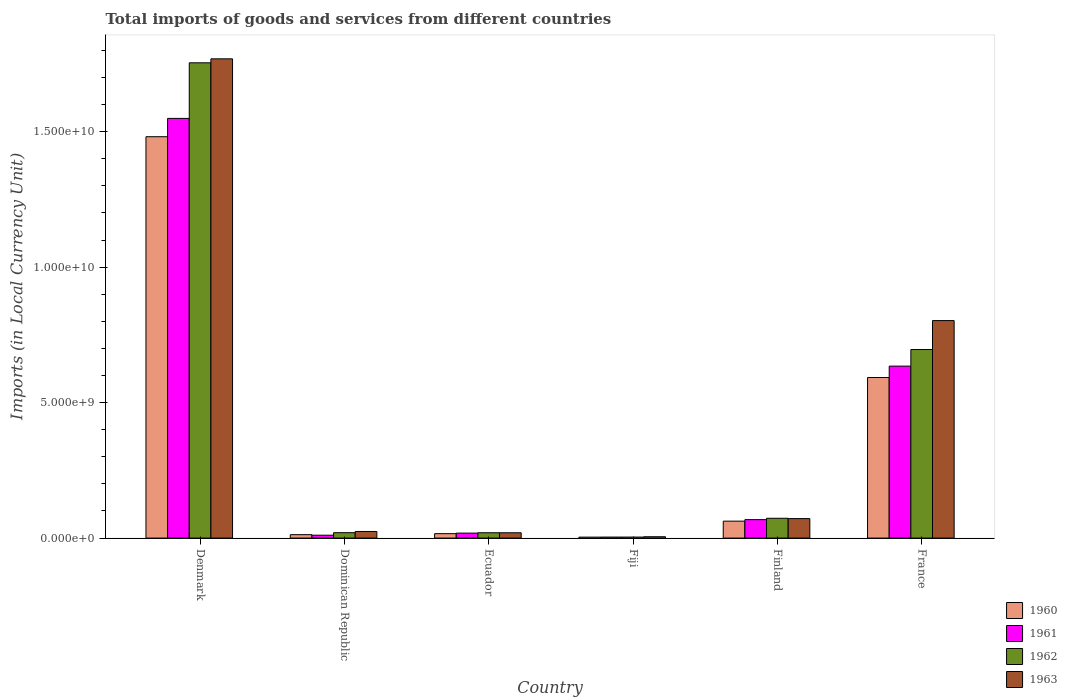Are the number of bars per tick equal to the number of legend labels?
Offer a very short reply. Yes. What is the label of the 4th group of bars from the left?
Make the answer very short. Fiji. In how many cases, is the number of bars for a given country not equal to the number of legend labels?
Provide a short and direct response. 0. What is the Amount of goods and services imports in 1960 in France?
Give a very brief answer. 5.93e+09. Across all countries, what is the maximum Amount of goods and services imports in 1962?
Ensure brevity in your answer.  1.75e+1. Across all countries, what is the minimum Amount of goods and services imports in 1961?
Your response must be concise. 3.79e+07. In which country was the Amount of goods and services imports in 1962 maximum?
Provide a short and direct response. Denmark. In which country was the Amount of goods and services imports in 1961 minimum?
Offer a terse response. Fiji. What is the total Amount of goods and services imports in 1962 in the graph?
Offer a terse response. 2.57e+1. What is the difference between the Amount of goods and services imports in 1961 in Denmark and that in France?
Your response must be concise. 9.14e+09. What is the difference between the Amount of goods and services imports in 1961 in Ecuador and the Amount of goods and services imports in 1960 in Finland?
Your answer should be compact. -4.42e+08. What is the average Amount of goods and services imports in 1961 per country?
Your answer should be compact. 3.81e+09. What is the difference between the Amount of goods and services imports of/in 1960 and Amount of goods and services imports of/in 1961 in Dominican Republic?
Your response must be concise. 1.96e+07. In how many countries, is the Amount of goods and services imports in 1963 greater than 5000000000 LCU?
Ensure brevity in your answer.  2. What is the ratio of the Amount of goods and services imports in 1962 in Dominican Republic to that in Fiji?
Make the answer very short. 5.26. Is the Amount of goods and services imports in 1963 in Ecuador less than that in France?
Provide a short and direct response. Yes. What is the difference between the highest and the second highest Amount of goods and services imports in 1962?
Your answer should be very brief. 1.06e+1. What is the difference between the highest and the lowest Amount of goods and services imports in 1960?
Your response must be concise. 1.48e+1. What does the 4th bar from the right in Ecuador represents?
Give a very brief answer. 1960. Is it the case that in every country, the sum of the Amount of goods and services imports in 1963 and Amount of goods and services imports in 1962 is greater than the Amount of goods and services imports in 1960?
Provide a short and direct response. Yes. How many bars are there?
Keep it short and to the point. 24. Are all the bars in the graph horizontal?
Offer a very short reply. No. What is the difference between two consecutive major ticks on the Y-axis?
Your answer should be compact. 5.00e+09. Are the values on the major ticks of Y-axis written in scientific E-notation?
Your answer should be compact. Yes. Where does the legend appear in the graph?
Your response must be concise. Bottom right. What is the title of the graph?
Make the answer very short. Total imports of goods and services from different countries. Does "1980" appear as one of the legend labels in the graph?
Give a very brief answer. No. What is the label or title of the Y-axis?
Ensure brevity in your answer.  Imports (in Local Currency Unit). What is the Imports (in Local Currency Unit) of 1960 in Denmark?
Ensure brevity in your answer.  1.48e+1. What is the Imports (in Local Currency Unit) in 1961 in Denmark?
Your answer should be very brief. 1.55e+1. What is the Imports (in Local Currency Unit) in 1962 in Denmark?
Your answer should be very brief. 1.75e+1. What is the Imports (in Local Currency Unit) in 1963 in Denmark?
Give a very brief answer. 1.77e+1. What is the Imports (in Local Currency Unit) of 1960 in Dominican Republic?
Provide a short and direct response. 1.26e+08. What is the Imports (in Local Currency Unit) in 1961 in Dominican Republic?
Keep it short and to the point. 1.07e+08. What is the Imports (in Local Currency Unit) of 1962 in Dominican Republic?
Ensure brevity in your answer.  1.99e+08. What is the Imports (in Local Currency Unit) in 1963 in Dominican Republic?
Your answer should be very brief. 2.44e+08. What is the Imports (in Local Currency Unit) of 1960 in Ecuador?
Provide a short and direct response. 1.64e+08. What is the Imports (in Local Currency Unit) of 1961 in Ecuador?
Offer a terse response. 1.83e+08. What is the Imports (in Local Currency Unit) of 1962 in Ecuador?
Provide a short and direct response. 1.97e+08. What is the Imports (in Local Currency Unit) of 1963 in Ecuador?
Provide a succinct answer. 1.96e+08. What is the Imports (in Local Currency Unit) of 1960 in Fiji?
Provide a succinct answer. 3.56e+07. What is the Imports (in Local Currency Unit) of 1961 in Fiji?
Offer a very short reply. 3.79e+07. What is the Imports (in Local Currency Unit) in 1962 in Fiji?
Offer a very short reply. 3.79e+07. What is the Imports (in Local Currency Unit) in 1960 in Finland?
Provide a succinct answer. 6.25e+08. What is the Imports (in Local Currency Unit) of 1961 in Finland?
Ensure brevity in your answer.  6.81e+08. What is the Imports (in Local Currency Unit) in 1962 in Finland?
Give a very brief answer. 7.32e+08. What is the Imports (in Local Currency Unit) in 1963 in Finland?
Ensure brevity in your answer.  7.19e+08. What is the Imports (in Local Currency Unit) in 1960 in France?
Your answer should be very brief. 5.93e+09. What is the Imports (in Local Currency Unit) in 1961 in France?
Your response must be concise. 6.35e+09. What is the Imports (in Local Currency Unit) of 1962 in France?
Your answer should be very brief. 6.96e+09. What is the Imports (in Local Currency Unit) in 1963 in France?
Give a very brief answer. 8.03e+09. Across all countries, what is the maximum Imports (in Local Currency Unit) of 1960?
Make the answer very short. 1.48e+1. Across all countries, what is the maximum Imports (in Local Currency Unit) in 1961?
Your answer should be compact. 1.55e+1. Across all countries, what is the maximum Imports (in Local Currency Unit) in 1962?
Ensure brevity in your answer.  1.75e+1. Across all countries, what is the maximum Imports (in Local Currency Unit) of 1963?
Offer a terse response. 1.77e+1. Across all countries, what is the minimum Imports (in Local Currency Unit) of 1960?
Make the answer very short. 3.56e+07. Across all countries, what is the minimum Imports (in Local Currency Unit) in 1961?
Offer a terse response. 3.79e+07. Across all countries, what is the minimum Imports (in Local Currency Unit) in 1962?
Ensure brevity in your answer.  3.79e+07. Across all countries, what is the minimum Imports (in Local Currency Unit) of 1963?
Give a very brief answer. 5.00e+07. What is the total Imports (in Local Currency Unit) of 1960 in the graph?
Offer a very short reply. 2.17e+1. What is the total Imports (in Local Currency Unit) of 1961 in the graph?
Give a very brief answer. 2.28e+1. What is the total Imports (in Local Currency Unit) of 1962 in the graph?
Provide a short and direct response. 2.57e+1. What is the total Imports (in Local Currency Unit) of 1963 in the graph?
Provide a succinct answer. 2.69e+1. What is the difference between the Imports (in Local Currency Unit) in 1960 in Denmark and that in Dominican Republic?
Offer a very short reply. 1.47e+1. What is the difference between the Imports (in Local Currency Unit) in 1961 in Denmark and that in Dominican Republic?
Offer a very short reply. 1.54e+1. What is the difference between the Imports (in Local Currency Unit) in 1962 in Denmark and that in Dominican Republic?
Provide a short and direct response. 1.73e+1. What is the difference between the Imports (in Local Currency Unit) of 1963 in Denmark and that in Dominican Republic?
Ensure brevity in your answer.  1.74e+1. What is the difference between the Imports (in Local Currency Unit) in 1960 in Denmark and that in Ecuador?
Keep it short and to the point. 1.47e+1. What is the difference between the Imports (in Local Currency Unit) in 1961 in Denmark and that in Ecuador?
Ensure brevity in your answer.  1.53e+1. What is the difference between the Imports (in Local Currency Unit) in 1962 in Denmark and that in Ecuador?
Ensure brevity in your answer.  1.73e+1. What is the difference between the Imports (in Local Currency Unit) in 1963 in Denmark and that in Ecuador?
Make the answer very short. 1.75e+1. What is the difference between the Imports (in Local Currency Unit) of 1960 in Denmark and that in Fiji?
Provide a short and direct response. 1.48e+1. What is the difference between the Imports (in Local Currency Unit) in 1961 in Denmark and that in Fiji?
Ensure brevity in your answer.  1.55e+1. What is the difference between the Imports (in Local Currency Unit) of 1962 in Denmark and that in Fiji?
Your answer should be compact. 1.75e+1. What is the difference between the Imports (in Local Currency Unit) of 1963 in Denmark and that in Fiji?
Your answer should be very brief. 1.76e+1. What is the difference between the Imports (in Local Currency Unit) in 1960 in Denmark and that in Finland?
Give a very brief answer. 1.42e+1. What is the difference between the Imports (in Local Currency Unit) in 1961 in Denmark and that in Finland?
Your response must be concise. 1.48e+1. What is the difference between the Imports (in Local Currency Unit) in 1962 in Denmark and that in Finland?
Make the answer very short. 1.68e+1. What is the difference between the Imports (in Local Currency Unit) in 1963 in Denmark and that in Finland?
Give a very brief answer. 1.70e+1. What is the difference between the Imports (in Local Currency Unit) of 1960 in Denmark and that in France?
Offer a very short reply. 8.89e+09. What is the difference between the Imports (in Local Currency Unit) of 1961 in Denmark and that in France?
Your answer should be very brief. 9.14e+09. What is the difference between the Imports (in Local Currency Unit) of 1962 in Denmark and that in France?
Provide a short and direct response. 1.06e+1. What is the difference between the Imports (in Local Currency Unit) of 1963 in Denmark and that in France?
Provide a short and direct response. 9.66e+09. What is the difference between the Imports (in Local Currency Unit) in 1960 in Dominican Republic and that in Ecuador?
Provide a short and direct response. -3.75e+07. What is the difference between the Imports (in Local Currency Unit) in 1961 in Dominican Republic and that in Ecuador?
Your answer should be compact. -7.66e+07. What is the difference between the Imports (in Local Currency Unit) of 1962 in Dominican Republic and that in Ecuador?
Your answer should be compact. 2.37e+06. What is the difference between the Imports (in Local Currency Unit) in 1963 in Dominican Republic and that in Ecuador?
Ensure brevity in your answer.  4.81e+07. What is the difference between the Imports (in Local Currency Unit) in 1960 in Dominican Republic and that in Fiji?
Keep it short and to the point. 9.09e+07. What is the difference between the Imports (in Local Currency Unit) in 1961 in Dominican Republic and that in Fiji?
Keep it short and to the point. 6.90e+07. What is the difference between the Imports (in Local Currency Unit) in 1962 in Dominican Republic and that in Fiji?
Provide a short and direct response. 1.61e+08. What is the difference between the Imports (in Local Currency Unit) in 1963 in Dominican Republic and that in Fiji?
Provide a succinct answer. 1.94e+08. What is the difference between the Imports (in Local Currency Unit) of 1960 in Dominican Republic and that in Finland?
Offer a terse response. -4.99e+08. What is the difference between the Imports (in Local Currency Unit) in 1961 in Dominican Republic and that in Finland?
Your answer should be very brief. -5.75e+08. What is the difference between the Imports (in Local Currency Unit) of 1962 in Dominican Republic and that in Finland?
Your response must be concise. -5.32e+08. What is the difference between the Imports (in Local Currency Unit) in 1963 in Dominican Republic and that in Finland?
Keep it short and to the point. -4.75e+08. What is the difference between the Imports (in Local Currency Unit) in 1960 in Dominican Republic and that in France?
Offer a very short reply. -5.80e+09. What is the difference between the Imports (in Local Currency Unit) in 1961 in Dominican Republic and that in France?
Offer a terse response. -6.24e+09. What is the difference between the Imports (in Local Currency Unit) of 1962 in Dominican Republic and that in France?
Provide a succinct answer. -6.76e+09. What is the difference between the Imports (in Local Currency Unit) of 1963 in Dominican Republic and that in France?
Keep it short and to the point. -7.78e+09. What is the difference between the Imports (in Local Currency Unit) in 1960 in Ecuador and that in Fiji?
Your answer should be very brief. 1.28e+08. What is the difference between the Imports (in Local Currency Unit) in 1961 in Ecuador and that in Fiji?
Your response must be concise. 1.46e+08. What is the difference between the Imports (in Local Currency Unit) of 1962 in Ecuador and that in Fiji?
Your answer should be very brief. 1.59e+08. What is the difference between the Imports (in Local Currency Unit) of 1963 in Ecuador and that in Fiji?
Your response must be concise. 1.46e+08. What is the difference between the Imports (in Local Currency Unit) of 1960 in Ecuador and that in Finland?
Provide a short and direct response. -4.61e+08. What is the difference between the Imports (in Local Currency Unit) in 1961 in Ecuador and that in Finland?
Keep it short and to the point. -4.98e+08. What is the difference between the Imports (in Local Currency Unit) in 1962 in Ecuador and that in Finland?
Make the answer very short. -5.35e+08. What is the difference between the Imports (in Local Currency Unit) in 1963 in Ecuador and that in Finland?
Offer a terse response. -5.23e+08. What is the difference between the Imports (in Local Currency Unit) of 1960 in Ecuador and that in France?
Your response must be concise. -5.76e+09. What is the difference between the Imports (in Local Currency Unit) of 1961 in Ecuador and that in France?
Your response must be concise. -6.16e+09. What is the difference between the Imports (in Local Currency Unit) of 1962 in Ecuador and that in France?
Your answer should be very brief. -6.76e+09. What is the difference between the Imports (in Local Currency Unit) of 1963 in Ecuador and that in France?
Your answer should be very brief. -7.83e+09. What is the difference between the Imports (in Local Currency Unit) in 1960 in Fiji and that in Finland?
Ensure brevity in your answer.  -5.90e+08. What is the difference between the Imports (in Local Currency Unit) of 1961 in Fiji and that in Finland?
Give a very brief answer. -6.44e+08. What is the difference between the Imports (in Local Currency Unit) in 1962 in Fiji and that in Finland?
Your response must be concise. -6.94e+08. What is the difference between the Imports (in Local Currency Unit) in 1963 in Fiji and that in Finland?
Provide a short and direct response. -6.69e+08. What is the difference between the Imports (in Local Currency Unit) in 1960 in Fiji and that in France?
Your answer should be compact. -5.89e+09. What is the difference between the Imports (in Local Currency Unit) in 1961 in Fiji and that in France?
Your answer should be very brief. -6.31e+09. What is the difference between the Imports (in Local Currency Unit) in 1962 in Fiji and that in France?
Offer a very short reply. -6.92e+09. What is the difference between the Imports (in Local Currency Unit) of 1963 in Fiji and that in France?
Keep it short and to the point. -7.98e+09. What is the difference between the Imports (in Local Currency Unit) of 1960 in Finland and that in France?
Make the answer very short. -5.30e+09. What is the difference between the Imports (in Local Currency Unit) in 1961 in Finland and that in France?
Provide a succinct answer. -5.67e+09. What is the difference between the Imports (in Local Currency Unit) of 1962 in Finland and that in France?
Keep it short and to the point. -6.23e+09. What is the difference between the Imports (in Local Currency Unit) in 1963 in Finland and that in France?
Keep it short and to the point. -7.31e+09. What is the difference between the Imports (in Local Currency Unit) in 1960 in Denmark and the Imports (in Local Currency Unit) in 1961 in Dominican Republic?
Make the answer very short. 1.47e+1. What is the difference between the Imports (in Local Currency Unit) in 1960 in Denmark and the Imports (in Local Currency Unit) in 1962 in Dominican Republic?
Your answer should be compact. 1.46e+1. What is the difference between the Imports (in Local Currency Unit) of 1960 in Denmark and the Imports (in Local Currency Unit) of 1963 in Dominican Republic?
Give a very brief answer. 1.46e+1. What is the difference between the Imports (in Local Currency Unit) of 1961 in Denmark and the Imports (in Local Currency Unit) of 1962 in Dominican Republic?
Your answer should be compact. 1.53e+1. What is the difference between the Imports (in Local Currency Unit) in 1961 in Denmark and the Imports (in Local Currency Unit) in 1963 in Dominican Republic?
Offer a terse response. 1.52e+1. What is the difference between the Imports (in Local Currency Unit) in 1962 in Denmark and the Imports (in Local Currency Unit) in 1963 in Dominican Republic?
Offer a very short reply. 1.73e+1. What is the difference between the Imports (in Local Currency Unit) of 1960 in Denmark and the Imports (in Local Currency Unit) of 1961 in Ecuador?
Offer a terse response. 1.46e+1. What is the difference between the Imports (in Local Currency Unit) in 1960 in Denmark and the Imports (in Local Currency Unit) in 1962 in Ecuador?
Your answer should be compact. 1.46e+1. What is the difference between the Imports (in Local Currency Unit) in 1960 in Denmark and the Imports (in Local Currency Unit) in 1963 in Ecuador?
Your answer should be compact. 1.46e+1. What is the difference between the Imports (in Local Currency Unit) in 1961 in Denmark and the Imports (in Local Currency Unit) in 1962 in Ecuador?
Give a very brief answer. 1.53e+1. What is the difference between the Imports (in Local Currency Unit) of 1961 in Denmark and the Imports (in Local Currency Unit) of 1963 in Ecuador?
Keep it short and to the point. 1.53e+1. What is the difference between the Imports (in Local Currency Unit) of 1962 in Denmark and the Imports (in Local Currency Unit) of 1963 in Ecuador?
Give a very brief answer. 1.73e+1. What is the difference between the Imports (in Local Currency Unit) in 1960 in Denmark and the Imports (in Local Currency Unit) in 1961 in Fiji?
Offer a terse response. 1.48e+1. What is the difference between the Imports (in Local Currency Unit) in 1960 in Denmark and the Imports (in Local Currency Unit) in 1962 in Fiji?
Your answer should be compact. 1.48e+1. What is the difference between the Imports (in Local Currency Unit) of 1960 in Denmark and the Imports (in Local Currency Unit) of 1963 in Fiji?
Keep it short and to the point. 1.48e+1. What is the difference between the Imports (in Local Currency Unit) in 1961 in Denmark and the Imports (in Local Currency Unit) in 1962 in Fiji?
Ensure brevity in your answer.  1.55e+1. What is the difference between the Imports (in Local Currency Unit) in 1961 in Denmark and the Imports (in Local Currency Unit) in 1963 in Fiji?
Ensure brevity in your answer.  1.54e+1. What is the difference between the Imports (in Local Currency Unit) of 1962 in Denmark and the Imports (in Local Currency Unit) of 1963 in Fiji?
Your response must be concise. 1.75e+1. What is the difference between the Imports (in Local Currency Unit) of 1960 in Denmark and the Imports (in Local Currency Unit) of 1961 in Finland?
Your answer should be compact. 1.41e+1. What is the difference between the Imports (in Local Currency Unit) in 1960 in Denmark and the Imports (in Local Currency Unit) in 1962 in Finland?
Offer a very short reply. 1.41e+1. What is the difference between the Imports (in Local Currency Unit) of 1960 in Denmark and the Imports (in Local Currency Unit) of 1963 in Finland?
Make the answer very short. 1.41e+1. What is the difference between the Imports (in Local Currency Unit) in 1961 in Denmark and the Imports (in Local Currency Unit) in 1962 in Finland?
Your answer should be compact. 1.48e+1. What is the difference between the Imports (in Local Currency Unit) of 1961 in Denmark and the Imports (in Local Currency Unit) of 1963 in Finland?
Ensure brevity in your answer.  1.48e+1. What is the difference between the Imports (in Local Currency Unit) of 1962 in Denmark and the Imports (in Local Currency Unit) of 1963 in Finland?
Keep it short and to the point. 1.68e+1. What is the difference between the Imports (in Local Currency Unit) of 1960 in Denmark and the Imports (in Local Currency Unit) of 1961 in France?
Offer a very short reply. 8.47e+09. What is the difference between the Imports (in Local Currency Unit) in 1960 in Denmark and the Imports (in Local Currency Unit) in 1962 in France?
Provide a succinct answer. 7.85e+09. What is the difference between the Imports (in Local Currency Unit) in 1960 in Denmark and the Imports (in Local Currency Unit) in 1963 in France?
Your answer should be compact. 6.79e+09. What is the difference between the Imports (in Local Currency Unit) in 1961 in Denmark and the Imports (in Local Currency Unit) in 1962 in France?
Give a very brief answer. 8.53e+09. What is the difference between the Imports (in Local Currency Unit) of 1961 in Denmark and the Imports (in Local Currency Unit) of 1963 in France?
Your answer should be compact. 7.46e+09. What is the difference between the Imports (in Local Currency Unit) of 1962 in Denmark and the Imports (in Local Currency Unit) of 1963 in France?
Give a very brief answer. 9.51e+09. What is the difference between the Imports (in Local Currency Unit) of 1960 in Dominican Republic and the Imports (in Local Currency Unit) of 1961 in Ecuador?
Your answer should be compact. -5.70e+07. What is the difference between the Imports (in Local Currency Unit) in 1960 in Dominican Republic and the Imports (in Local Currency Unit) in 1962 in Ecuador?
Offer a terse response. -7.04e+07. What is the difference between the Imports (in Local Currency Unit) in 1960 in Dominican Republic and the Imports (in Local Currency Unit) in 1963 in Ecuador?
Your response must be concise. -6.98e+07. What is the difference between the Imports (in Local Currency Unit) of 1961 in Dominican Republic and the Imports (in Local Currency Unit) of 1962 in Ecuador?
Offer a terse response. -9.00e+07. What is the difference between the Imports (in Local Currency Unit) in 1961 in Dominican Republic and the Imports (in Local Currency Unit) in 1963 in Ecuador?
Ensure brevity in your answer.  -8.94e+07. What is the difference between the Imports (in Local Currency Unit) in 1962 in Dominican Republic and the Imports (in Local Currency Unit) in 1963 in Ecuador?
Offer a terse response. 3.04e+06. What is the difference between the Imports (in Local Currency Unit) in 1960 in Dominican Republic and the Imports (in Local Currency Unit) in 1961 in Fiji?
Your response must be concise. 8.86e+07. What is the difference between the Imports (in Local Currency Unit) in 1960 in Dominican Republic and the Imports (in Local Currency Unit) in 1962 in Fiji?
Ensure brevity in your answer.  8.86e+07. What is the difference between the Imports (in Local Currency Unit) of 1960 in Dominican Republic and the Imports (in Local Currency Unit) of 1963 in Fiji?
Your answer should be very brief. 7.65e+07. What is the difference between the Imports (in Local Currency Unit) of 1961 in Dominican Republic and the Imports (in Local Currency Unit) of 1962 in Fiji?
Your answer should be compact. 6.90e+07. What is the difference between the Imports (in Local Currency Unit) of 1961 in Dominican Republic and the Imports (in Local Currency Unit) of 1963 in Fiji?
Offer a terse response. 5.69e+07. What is the difference between the Imports (in Local Currency Unit) of 1962 in Dominican Republic and the Imports (in Local Currency Unit) of 1963 in Fiji?
Provide a succinct answer. 1.49e+08. What is the difference between the Imports (in Local Currency Unit) of 1960 in Dominican Republic and the Imports (in Local Currency Unit) of 1961 in Finland?
Offer a terse response. -5.55e+08. What is the difference between the Imports (in Local Currency Unit) in 1960 in Dominican Republic and the Imports (in Local Currency Unit) in 1962 in Finland?
Make the answer very short. -6.05e+08. What is the difference between the Imports (in Local Currency Unit) in 1960 in Dominican Republic and the Imports (in Local Currency Unit) in 1963 in Finland?
Give a very brief answer. -5.93e+08. What is the difference between the Imports (in Local Currency Unit) of 1961 in Dominican Republic and the Imports (in Local Currency Unit) of 1962 in Finland?
Provide a succinct answer. -6.25e+08. What is the difference between the Imports (in Local Currency Unit) of 1961 in Dominican Republic and the Imports (in Local Currency Unit) of 1963 in Finland?
Offer a very short reply. -6.12e+08. What is the difference between the Imports (in Local Currency Unit) in 1962 in Dominican Republic and the Imports (in Local Currency Unit) in 1963 in Finland?
Your response must be concise. -5.20e+08. What is the difference between the Imports (in Local Currency Unit) of 1960 in Dominican Republic and the Imports (in Local Currency Unit) of 1961 in France?
Give a very brief answer. -6.22e+09. What is the difference between the Imports (in Local Currency Unit) of 1960 in Dominican Republic and the Imports (in Local Currency Unit) of 1962 in France?
Ensure brevity in your answer.  -6.83e+09. What is the difference between the Imports (in Local Currency Unit) in 1960 in Dominican Republic and the Imports (in Local Currency Unit) in 1963 in France?
Your answer should be very brief. -7.90e+09. What is the difference between the Imports (in Local Currency Unit) of 1961 in Dominican Republic and the Imports (in Local Currency Unit) of 1962 in France?
Provide a succinct answer. -6.85e+09. What is the difference between the Imports (in Local Currency Unit) of 1961 in Dominican Republic and the Imports (in Local Currency Unit) of 1963 in France?
Ensure brevity in your answer.  -7.92e+09. What is the difference between the Imports (in Local Currency Unit) in 1962 in Dominican Republic and the Imports (in Local Currency Unit) in 1963 in France?
Provide a succinct answer. -7.83e+09. What is the difference between the Imports (in Local Currency Unit) in 1960 in Ecuador and the Imports (in Local Currency Unit) in 1961 in Fiji?
Your response must be concise. 1.26e+08. What is the difference between the Imports (in Local Currency Unit) of 1960 in Ecuador and the Imports (in Local Currency Unit) of 1962 in Fiji?
Give a very brief answer. 1.26e+08. What is the difference between the Imports (in Local Currency Unit) in 1960 in Ecuador and the Imports (in Local Currency Unit) in 1963 in Fiji?
Your answer should be very brief. 1.14e+08. What is the difference between the Imports (in Local Currency Unit) of 1961 in Ecuador and the Imports (in Local Currency Unit) of 1962 in Fiji?
Your answer should be compact. 1.46e+08. What is the difference between the Imports (in Local Currency Unit) in 1961 in Ecuador and the Imports (in Local Currency Unit) in 1963 in Fiji?
Provide a succinct answer. 1.33e+08. What is the difference between the Imports (in Local Currency Unit) of 1962 in Ecuador and the Imports (in Local Currency Unit) of 1963 in Fiji?
Give a very brief answer. 1.47e+08. What is the difference between the Imports (in Local Currency Unit) of 1960 in Ecuador and the Imports (in Local Currency Unit) of 1961 in Finland?
Offer a terse response. -5.17e+08. What is the difference between the Imports (in Local Currency Unit) in 1960 in Ecuador and the Imports (in Local Currency Unit) in 1962 in Finland?
Ensure brevity in your answer.  -5.68e+08. What is the difference between the Imports (in Local Currency Unit) in 1960 in Ecuador and the Imports (in Local Currency Unit) in 1963 in Finland?
Keep it short and to the point. -5.55e+08. What is the difference between the Imports (in Local Currency Unit) in 1961 in Ecuador and the Imports (in Local Currency Unit) in 1962 in Finland?
Make the answer very short. -5.48e+08. What is the difference between the Imports (in Local Currency Unit) in 1961 in Ecuador and the Imports (in Local Currency Unit) in 1963 in Finland?
Keep it short and to the point. -5.36e+08. What is the difference between the Imports (in Local Currency Unit) of 1962 in Ecuador and the Imports (in Local Currency Unit) of 1963 in Finland?
Make the answer very short. -5.22e+08. What is the difference between the Imports (in Local Currency Unit) of 1960 in Ecuador and the Imports (in Local Currency Unit) of 1961 in France?
Ensure brevity in your answer.  -6.18e+09. What is the difference between the Imports (in Local Currency Unit) in 1960 in Ecuador and the Imports (in Local Currency Unit) in 1962 in France?
Provide a succinct answer. -6.80e+09. What is the difference between the Imports (in Local Currency Unit) of 1960 in Ecuador and the Imports (in Local Currency Unit) of 1963 in France?
Give a very brief answer. -7.86e+09. What is the difference between the Imports (in Local Currency Unit) in 1961 in Ecuador and the Imports (in Local Currency Unit) in 1962 in France?
Your answer should be very brief. -6.78e+09. What is the difference between the Imports (in Local Currency Unit) in 1961 in Ecuador and the Imports (in Local Currency Unit) in 1963 in France?
Ensure brevity in your answer.  -7.84e+09. What is the difference between the Imports (in Local Currency Unit) in 1962 in Ecuador and the Imports (in Local Currency Unit) in 1963 in France?
Your response must be concise. -7.83e+09. What is the difference between the Imports (in Local Currency Unit) in 1960 in Fiji and the Imports (in Local Currency Unit) in 1961 in Finland?
Give a very brief answer. -6.46e+08. What is the difference between the Imports (in Local Currency Unit) in 1960 in Fiji and the Imports (in Local Currency Unit) in 1962 in Finland?
Ensure brevity in your answer.  -6.96e+08. What is the difference between the Imports (in Local Currency Unit) in 1960 in Fiji and the Imports (in Local Currency Unit) in 1963 in Finland?
Provide a succinct answer. -6.84e+08. What is the difference between the Imports (in Local Currency Unit) in 1961 in Fiji and the Imports (in Local Currency Unit) in 1962 in Finland?
Offer a very short reply. -6.94e+08. What is the difference between the Imports (in Local Currency Unit) of 1961 in Fiji and the Imports (in Local Currency Unit) of 1963 in Finland?
Make the answer very short. -6.81e+08. What is the difference between the Imports (in Local Currency Unit) of 1962 in Fiji and the Imports (in Local Currency Unit) of 1963 in Finland?
Keep it short and to the point. -6.81e+08. What is the difference between the Imports (in Local Currency Unit) in 1960 in Fiji and the Imports (in Local Currency Unit) in 1961 in France?
Make the answer very short. -6.31e+09. What is the difference between the Imports (in Local Currency Unit) in 1960 in Fiji and the Imports (in Local Currency Unit) in 1962 in France?
Provide a short and direct response. -6.92e+09. What is the difference between the Imports (in Local Currency Unit) of 1960 in Fiji and the Imports (in Local Currency Unit) of 1963 in France?
Offer a very short reply. -7.99e+09. What is the difference between the Imports (in Local Currency Unit) of 1961 in Fiji and the Imports (in Local Currency Unit) of 1962 in France?
Make the answer very short. -6.92e+09. What is the difference between the Imports (in Local Currency Unit) of 1961 in Fiji and the Imports (in Local Currency Unit) of 1963 in France?
Make the answer very short. -7.99e+09. What is the difference between the Imports (in Local Currency Unit) in 1962 in Fiji and the Imports (in Local Currency Unit) in 1963 in France?
Provide a short and direct response. -7.99e+09. What is the difference between the Imports (in Local Currency Unit) of 1960 in Finland and the Imports (in Local Currency Unit) of 1961 in France?
Offer a very short reply. -5.72e+09. What is the difference between the Imports (in Local Currency Unit) of 1960 in Finland and the Imports (in Local Currency Unit) of 1962 in France?
Your response must be concise. -6.33e+09. What is the difference between the Imports (in Local Currency Unit) in 1960 in Finland and the Imports (in Local Currency Unit) in 1963 in France?
Provide a short and direct response. -7.40e+09. What is the difference between the Imports (in Local Currency Unit) of 1961 in Finland and the Imports (in Local Currency Unit) of 1962 in France?
Give a very brief answer. -6.28e+09. What is the difference between the Imports (in Local Currency Unit) in 1961 in Finland and the Imports (in Local Currency Unit) in 1963 in France?
Make the answer very short. -7.35e+09. What is the difference between the Imports (in Local Currency Unit) of 1962 in Finland and the Imports (in Local Currency Unit) of 1963 in France?
Your response must be concise. -7.30e+09. What is the average Imports (in Local Currency Unit) of 1960 per country?
Give a very brief answer. 3.62e+09. What is the average Imports (in Local Currency Unit) of 1961 per country?
Provide a short and direct response. 3.81e+09. What is the average Imports (in Local Currency Unit) of 1962 per country?
Provide a succinct answer. 4.28e+09. What is the average Imports (in Local Currency Unit) in 1963 per country?
Offer a very short reply. 4.49e+09. What is the difference between the Imports (in Local Currency Unit) in 1960 and Imports (in Local Currency Unit) in 1961 in Denmark?
Your answer should be very brief. -6.76e+08. What is the difference between the Imports (in Local Currency Unit) of 1960 and Imports (in Local Currency Unit) of 1962 in Denmark?
Make the answer very short. -2.73e+09. What is the difference between the Imports (in Local Currency Unit) of 1960 and Imports (in Local Currency Unit) of 1963 in Denmark?
Keep it short and to the point. -2.87e+09. What is the difference between the Imports (in Local Currency Unit) in 1961 and Imports (in Local Currency Unit) in 1962 in Denmark?
Your answer should be very brief. -2.05e+09. What is the difference between the Imports (in Local Currency Unit) in 1961 and Imports (in Local Currency Unit) in 1963 in Denmark?
Offer a very short reply. -2.20e+09. What is the difference between the Imports (in Local Currency Unit) in 1962 and Imports (in Local Currency Unit) in 1963 in Denmark?
Give a very brief answer. -1.47e+08. What is the difference between the Imports (in Local Currency Unit) in 1960 and Imports (in Local Currency Unit) in 1961 in Dominican Republic?
Your answer should be very brief. 1.96e+07. What is the difference between the Imports (in Local Currency Unit) in 1960 and Imports (in Local Currency Unit) in 1962 in Dominican Republic?
Give a very brief answer. -7.28e+07. What is the difference between the Imports (in Local Currency Unit) of 1960 and Imports (in Local Currency Unit) of 1963 in Dominican Republic?
Make the answer very short. -1.18e+08. What is the difference between the Imports (in Local Currency Unit) of 1961 and Imports (in Local Currency Unit) of 1962 in Dominican Republic?
Your answer should be very brief. -9.24e+07. What is the difference between the Imports (in Local Currency Unit) of 1961 and Imports (in Local Currency Unit) of 1963 in Dominican Republic?
Your answer should be compact. -1.38e+08. What is the difference between the Imports (in Local Currency Unit) of 1962 and Imports (in Local Currency Unit) of 1963 in Dominican Republic?
Provide a succinct answer. -4.51e+07. What is the difference between the Imports (in Local Currency Unit) of 1960 and Imports (in Local Currency Unit) of 1961 in Ecuador?
Offer a very short reply. -1.95e+07. What is the difference between the Imports (in Local Currency Unit) of 1960 and Imports (in Local Currency Unit) of 1962 in Ecuador?
Offer a very short reply. -3.29e+07. What is the difference between the Imports (in Local Currency Unit) of 1960 and Imports (in Local Currency Unit) of 1963 in Ecuador?
Your response must be concise. -3.23e+07. What is the difference between the Imports (in Local Currency Unit) in 1961 and Imports (in Local Currency Unit) in 1962 in Ecuador?
Provide a succinct answer. -1.34e+07. What is the difference between the Imports (in Local Currency Unit) in 1961 and Imports (in Local Currency Unit) in 1963 in Ecuador?
Provide a short and direct response. -1.28e+07. What is the difference between the Imports (in Local Currency Unit) of 1962 and Imports (in Local Currency Unit) of 1963 in Ecuador?
Provide a succinct answer. 6.72e+05. What is the difference between the Imports (in Local Currency Unit) of 1960 and Imports (in Local Currency Unit) of 1961 in Fiji?
Your answer should be compact. -2.30e+06. What is the difference between the Imports (in Local Currency Unit) of 1960 and Imports (in Local Currency Unit) of 1962 in Fiji?
Offer a very short reply. -2.30e+06. What is the difference between the Imports (in Local Currency Unit) of 1960 and Imports (in Local Currency Unit) of 1963 in Fiji?
Your answer should be very brief. -1.44e+07. What is the difference between the Imports (in Local Currency Unit) in 1961 and Imports (in Local Currency Unit) in 1962 in Fiji?
Provide a succinct answer. 0. What is the difference between the Imports (in Local Currency Unit) of 1961 and Imports (in Local Currency Unit) of 1963 in Fiji?
Keep it short and to the point. -1.21e+07. What is the difference between the Imports (in Local Currency Unit) in 1962 and Imports (in Local Currency Unit) in 1963 in Fiji?
Provide a short and direct response. -1.21e+07. What is the difference between the Imports (in Local Currency Unit) of 1960 and Imports (in Local Currency Unit) of 1961 in Finland?
Provide a succinct answer. -5.61e+07. What is the difference between the Imports (in Local Currency Unit) in 1960 and Imports (in Local Currency Unit) in 1962 in Finland?
Keep it short and to the point. -1.06e+08. What is the difference between the Imports (in Local Currency Unit) of 1960 and Imports (in Local Currency Unit) of 1963 in Finland?
Your answer should be compact. -9.39e+07. What is the difference between the Imports (in Local Currency Unit) in 1961 and Imports (in Local Currency Unit) in 1962 in Finland?
Keep it short and to the point. -5.01e+07. What is the difference between the Imports (in Local Currency Unit) in 1961 and Imports (in Local Currency Unit) in 1963 in Finland?
Make the answer very short. -3.78e+07. What is the difference between the Imports (in Local Currency Unit) in 1962 and Imports (in Local Currency Unit) in 1963 in Finland?
Give a very brief answer. 1.23e+07. What is the difference between the Imports (in Local Currency Unit) in 1960 and Imports (in Local Currency Unit) in 1961 in France?
Your answer should be compact. -4.20e+08. What is the difference between the Imports (in Local Currency Unit) in 1960 and Imports (in Local Currency Unit) in 1962 in France?
Give a very brief answer. -1.03e+09. What is the difference between the Imports (in Local Currency Unit) in 1960 and Imports (in Local Currency Unit) in 1963 in France?
Ensure brevity in your answer.  -2.10e+09. What is the difference between the Imports (in Local Currency Unit) of 1961 and Imports (in Local Currency Unit) of 1962 in France?
Offer a very short reply. -6.12e+08. What is the difference between the Imports (in Local Currency Unit) in 1961 and Imports (in Local Currency Unit) in 1963 in France?
Offer a very short reply. -1.68e+09. What is the difference between the Imports (in Local Currency Unit) of 1962 and Imports (in Local Currency Unit) of 1963 in France?
Ensure brevity in your answer.  -1.07e+09. What is the ratio of the Imports (in Local Currency Unit) in 1960 in Denmark to that in Dominican Republic?
Ensure brevity in your answer.  117.11. What is the ratio of the Imports (in Local Currency Unit) in 1961 in Denmark to that in Dominican Republic?
Your answer should be very brief. 144.9. What is the ratio of the Imports (in Local Currency Unit) of 1962 in Denmark to that in Dominican Republic?
Your answer should be compact. 88.01. What is the ratio of the Imports (in Local Currency Unit) in 1963 in Denmark to that in Dominican Republic?
Ensure brevity in your answer.  72.37. What is the ratio of the Imports (in Local Currency Unit) of 1960 in Denmark to that in Ecuador?
Your answer should be compact. 90.33. What is the ratio of the Imports (in Local Currency Unit) of 1961 in Denmark to that in Ecuador?
Your answer should be compact. 84.42. What is the ratio of the Imports (in Local Currency Unit) of 1962 in Denmark to that in Ecuador?
Provide a succinct answer. 89.07. What is the ratio of the Imports (in Local Currency Unit) in 1963 in Denmark to that in Ecuador?
Your answer should be compact. 90.12. What is the ratio of the Imports (in Local Currency Unit) of 1960 in Denmark to that in Fiji?
Give a very brief answer. 416.13. What is the ratio of the Imports (in Local Currency Unit) in 1961 in Denmark to that in Fiji?
Your answer should be compact. 408.7. What is the ratio of the Imports (in Local Currency Unit) in 1962 in Denmark to that in Fiji?
Give a very brief answer. 462.83. What is the ratio of the Imports (in Local Currency Unit) of 1963 in Denmark to that in Fiji?
Your response must be concise. 353.76. What is the ratio of the Imports (in Local Currency Unit) in 1960 in Denmark to that in Finland?
Offer a terse response. 23.69. What is the ratio of the Imports (in Local Currency Unit) in 1961 in Denmark to that in Finland?
Offer a very short reply. 22.73. What is the ratio of the Imports (in Local Currency Unit) in 1962 in Denmark to that in Finland?
Provide a succinct answer. 23.98. What is the ratio of the Imports (in Local Currency Unit) of 1963 in Denmark to that in Finland?
Keep it short and to the point. 24.59. What is the ratio of the Imports (in Local Currency Unit) of 1960 in Denmark to that in France?
Offer a terse response. 2.5. What is the ratio of the Imports (in Local Currency Unit) in 1961 in Denmark to that in France?
Provide a short and direct response. 2.44. What is the ratio of the Imports (in Local Currency Unit) of 1962 in Denmark to that in France?
Make the answer very short. 2.52. What is the ratio of the Imports (in Local Currency Unit) in 1963 in Denmark to that in France?
Your response must be concise. 2.2. What is the ratio of the Imports (in Local Currency Unit) of 1960 in Dominican Republic to that in Ecuador?
Offer a very short reply. 0.77. What is the ratio of the Imports (in Local Currency Unit) of 1961 in Dominican Republic to that in Ecuador?
Provide a short and direct response. 0.58. What is the ratio of the Imports (in Local Currency Unit) of 1962 in Dominican Republic to that in Ecuador?
Give a very brief answer. 1.01. What is the ratio of the Imports (in Local Currency Unit) of 1963 in Dominican Republic to that in Ecuador?
Give a very brief answer. 1.25. What is the ratio of the Imports (in Local Currency Unit) in 1960 in Dominican Republic to that in Fiji?
Ensure brevity in your answer.  3.55. What is the ratio of the Imports (in Local Currency Unit) in 1961 in Dominican Republic to that in Fiji?
Make the answer very short. 2.82. What is the ratio of the Imports (in Local Currency Unit) in 1962 in Dominican Republic to that in Fiji?
Offer a very short reply. 5.26. What is the ratio of the Imports (in Local Currency Unit) of 1963 in Dominican Republic to that in Fiji?
Offer a very short reply. 4.89. What is the ratio of the Imports (in Local Currency Unit) in 1960 in Dominican Republic to that in Finland?
Your response must be concise. 0.2. What is the ratio of the Imports (in Local Currency Unit) of 1961 in Dominican Republic to that in Finland?
Your response must be concise. 0.16. What is the ratio of the Imports (in Local Currency Unit) in 1962 in Dominican Republic to that in Finland?
Give a very brief answer. 0.27. What is the ratio of the Imports (in Local Currency Unit) in 1963 in Dominican Republic to that in Finland?
Provide a short and direct response. 0.34. What is the ratio of the Imports (in Local Currency Unit) of 1960 in Dominican Republic to that in France?
Your response must be concise. 0.02. What is the ratio of the Imports (in Local Currency Unit) of 1961 in Dominican Republic to that in France?
Provide a succinct answer. 0.02. What is the ratio of the Imports (in Local Currency Unit) in 1962 in Dominican Republic to that in France?
Provide a succinct answer. 0.03. What is the ratio of the Imports (in Local Currency Unit) of 1963 in Dominican Republic to that in France?
Provide a succinct answer. 0.03. What is the ratio of the Imports (in Local Currency Unit) of 1960 in Ecuador to that in Fiji?
Make the answer very short. 4.61. What is the ratio of the Imports (in Local Currency Unit) of 1961 in Ecuador to that in Fiji?
Ensure brevity in your answer.  4.84. What is the ratio of the Imports (in Local Currency Unit) in 1962 in Ecuador to that in Fiji?
Give a very brief answer. 5.2. What is the ratio of the Imports (in Local Currency Unit) in 1963 in Ecuador to that in Fiji?
Your answer should be very brief. 3.93. What is the ratio of the Imports (in Local Currency Unit) of 1960 in Ecuador to that in Finland?
Offer a terse response. 0.26. What is the ratio of the Imports (in Local Currency Unit) in 1961 in Ecuador to that in Finland?
Keep it short and to the point. 0.27. What is the ratio of the Imports (in Local Currency Unit) in 1962 in Ecuador to that in Finland?
Offer a very short reply. 0.27. What is the ratio of the Imports (in Local Currency Unit) of 1963 in Ecuador to that in Finland?
Provide a short and direct response. 0.27. What is the ratio of the Imports (in Local Currency Unit) in 1960 in Ecuador to that in France?
Keep it short and to the point. 0.03. What is the ratio of the Imports (in Local Currency Unit) of 1961 in Ecuador to that in France?
Your answer should be very brief. 0.03. What is the ratio of the Imports (in Local Currency Unit) of 1962 in Ecuador to that in France?
Your response must be concise. 0.03. What is the ratio of the Imports (in Local Currency Unit) in 1963 in Ecuador to that in France?
Your answer should be very brief. 0.02. What is the ratio of the Imports (in Local Currency Unit) in 1960 in Fiji to that in Finland?
Offer a very short reply. 0.06. What is the ratio of the Imports (in Local Currency Unit) of 1961 in Fiji to that in Finland?
Provide a short and direct response. 0.06. What is the ratio of the Imports (in Local Currency Unit) in 1962 in Fiji to that in Finland?
Make the answer very short. 0.05. What is the ratio of the Imports (in Local Currency Unit) of 1963 in Fiji to that in Finland?
Your response must be concise. 0.07. What is the ratio of the Imports (in Local Currency Unit) of 1960 in Fiji to that in France?
Make the answer very short. 0.01. What is the ratio of the Imports (in Local Currency Unit) of 1961 in Fiji to that in France?
Provide a short and direct response. 0.01. What is the ratio of the Imports (in Local Currency Unit) of 1962 in Fiji to that in France?
Your response must be concise. 0.01. What is the ratio of the Imports (in Local Currency Unit) in 1963 in Fiji to that in France?
Your answer should be very brief. 0.01. What is the ratio of the Imports (in Local Currency Unit) of 1960 in Finland to that in France?
Ensure brevity in your answer.  0.11. What is the ratio of the Imports (in Local Currency Unit) of 1961 in Finland to that in France?
Offer a terse response. 0.11. What is the ratio of the Imports (in Local Currency Unit) in 1962 in Finland to that in France?
Provide a short and direct response. 0.11. What is the ratio of the Imports (in Local Currency Unit) in 1963 in Finland to that in France?
Your response must be concise. 0.09. What is the difference between the highest and the second highest Imports (in Local Currency Unit) of 1960?
Provide a succinct answer. 8.89e+09. What is the difference between the highest and the second highest Imports (in Local Currency Unit) in 1961?
Keep it short and to the point. 9.14e+09. What is the difference between the highest and the second highest Imports (in Local Currency Unit) in 1962?
Your response must be concise. 1.06e+1. What is the difference between the highest and the second highest Imports (in Local Currency Unit) of 1963?
Offer a very short reply. 9.66e+09. What is the difference between the highest and the lowest Imports (in Local Currency Unit) in 1960?
Ensure brevity in your answer.  1.48e+1. What is the difference between the highest and the lowest Imports (in Local Currency Unit) of 1961?
Your response must be concise. 1.55e+1. What is the difference between the highest and the lowest Imports (in Local Currency Unit) of 1962?
Your answer should be very brief. 1.75e+1. What is the difference between the highest and the lowest Imports (in Local Currency Unit) in 1963?
Offer a terse response. 1.76e+1. 